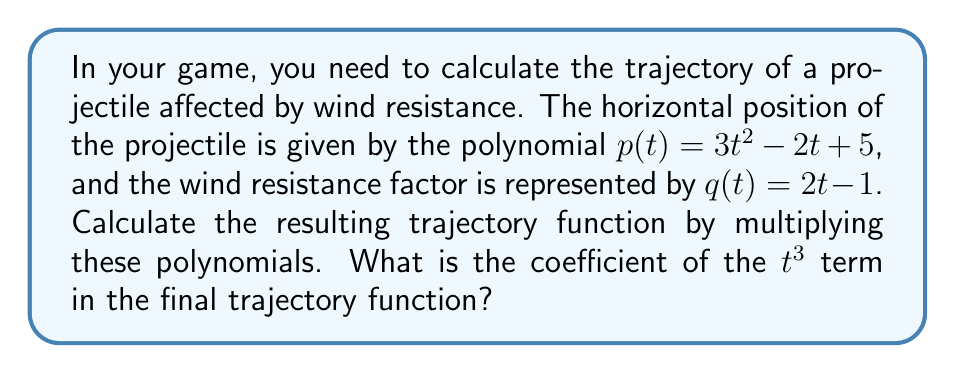Can you answer this question? To solve this problem, we need to multiply the two polynomials $p(t)$ and $q(t)$. Let's break it down step-by-step:

1) Given polynomials:
   $p(t) = 3t^2 - 2t + 5$
   $q(t) = 2t - 1$

2) To multiply these polynomials, we need to multiply each term of $p(t)$ by each term of $q(t)$:

   $(3t^2 - 2t + 5)(2t - 1)$

3) Let's multiply term by term:
   
   $3t^2 \cdot 2t = 6t^3$
   $3t^2 \cdot (-1) = -3t^2$
   $-2t \cdot 2t = -4t^2$
   $-2t \cdot (-1) = 2t$
   $5 \cdot 2t = 10t$
   $5 \cdot (-1) = -5$

4) Now, let's combine like terms:

   $6t^3 - 3t^2 - 4t^2 + 2t + 10t - 5$

5) Simplifying:

   $6t^3 - 7t^2 + 12t - 5$

6) The coefficient of the $t^3$ term in this final trajectory function is 6.
Answer: 6 